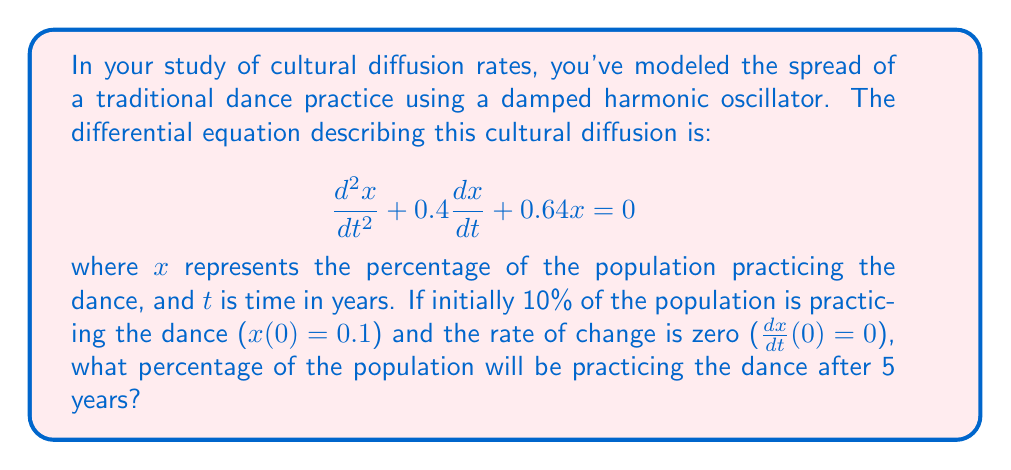Help me with this question. To solve this problem, we need to follow these steps:

1) First, we identify this as a second-order linear homogeneous differential equation with constant coefficients in the form:

   $$\frac{d^2x}{dt^2} + 2\zeta\omega_n\frac{dx}{dt} + \omega_n^2x = 0$$

   where $\zeta$ is the damping ratio and $\omega_n$ is the natural frequency.

2) In our case, $2\zeta\omega_n = 0.4$ and $\omega_n^2 = 0.64$. So, $\omega_n = 0.8$ and $\zeta = 0.25$.

3) Since $0 < \zeta < 1$, this is an underdamped system. The general solution for an underdamped system is:

   $$x(t) = e^{-\zeta\omega_nt}(A\cos(\omega_dt) + B\sin(\omega_dt))$$

   where $\omega_d = \omega_n\sqrt{1-\zeta^2}$ is the damped natural frequency.

4) Calculate $\omega_d$:
   $$\omega_d = 0.8\sqrt{1-0.25^2} \approx 0.7746$$

5) Now we have:
   $$x(t) = e^{-0.2t}(A\cos(0.7746t) + B\sin(0.7746t))$$

6) Use the initial conditions to find A and B:
   - $x(0) = 0.1$, so $A = 0.1$
   - $\frac{dx}{dt}(0) = 0$, so $-0.2A + 0.7746B = 0$
     Therefore, $B = \frac{0.2 \cdot 0.1}{0.7746} \approx 0.0258$

7) Our final solution is:
   $$x(t) = e^{-0.2t}(0.1\cos(0.7746t) + 0.0258\sin(0.7746t))$$

8) To find the percentage after 5 years, we evaluate $x(5)$:
   $$x(5) = e^{-0.2 \cdot 5}(0.1\cos(0.7746 \cdot 5) + 0.0258\sin(0.7746 \cdot 5))$$

9) Calculating this gives us approximately 0.0376 or 3.76%.
Answer: After 5 years, approximately 3.76% of the population will be practicing the traditional dance. 